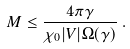<formula> <loc_0><loc_0><loc_500><loc_500>M \leq \frac { 4 \pi \gamma } { \chi _ { 0 } | V | \Omega ( \gamma ) } \, .</formula> 